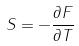<formula> <loc_0><loc_0><loc_500><loc_500>S = - \frac { \partial F } { \partial T }</formula> 